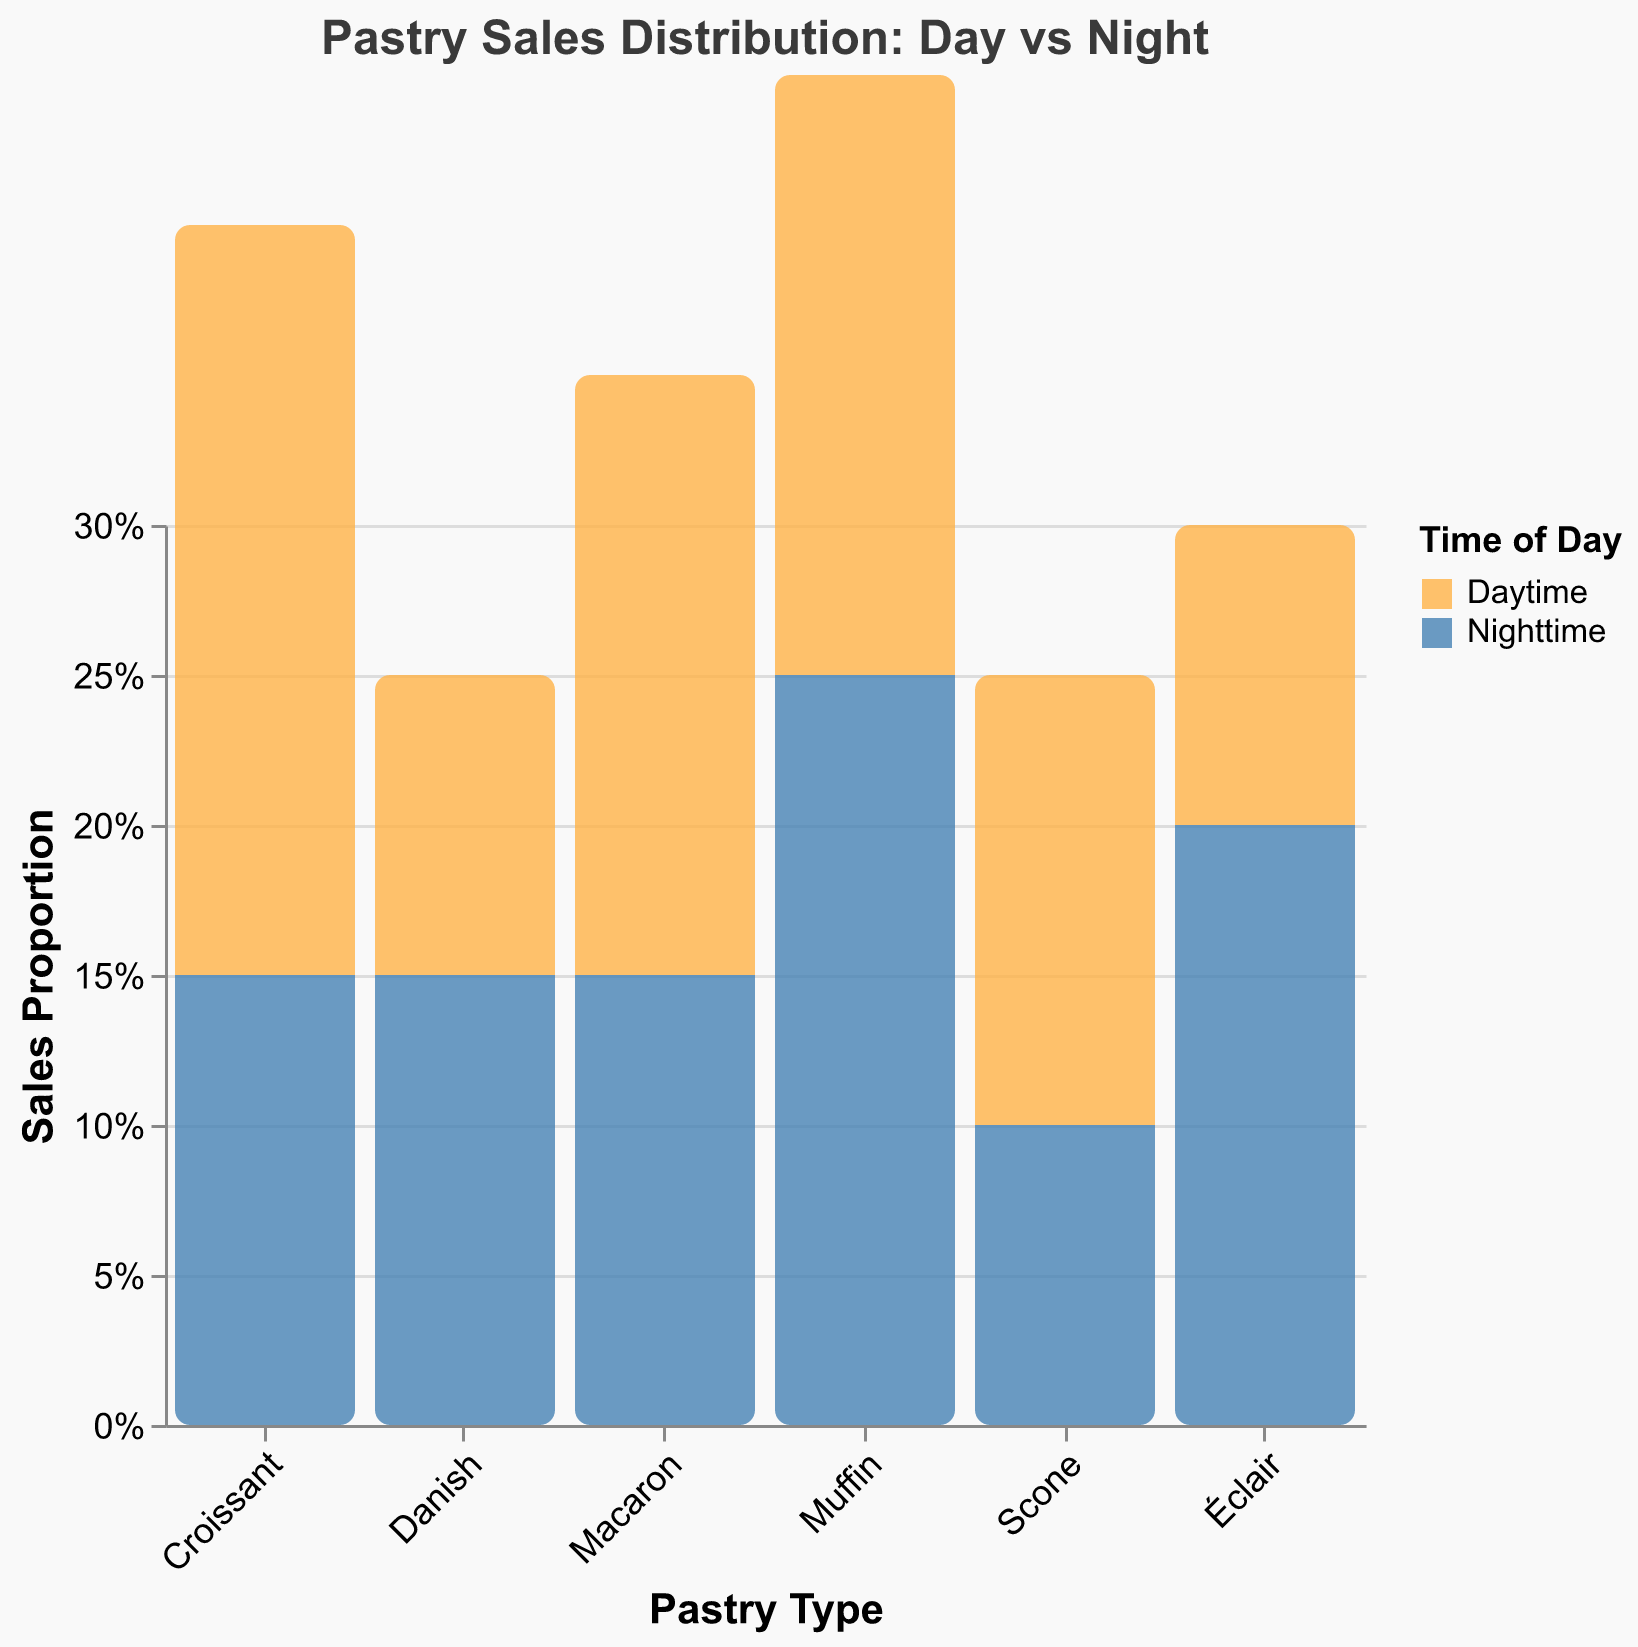What is the title of the chart? The title of the chart is displayed at the top of the figure.
Answer: Pastry Sales Distribution: Day vs Night What colors represent daytime and nighttime in the chart? The legend at the right of the chart shows the relationship between colors and time of day. Daytime is represented by an orange color, and nighttime is represented by a blue color.
Answer: Orange for daytime and blue for nighttime Which pastry type has the highest sales proportion during nighttime? By looking at the different bars colored in blue, we find the tallest bar for nighttime sales proportion. The Éclair bar is the highest at nighttime with a sales proportion of 0.20.
Answer: Éclair How does the sales proportion of muffins compare between daytime and nighttime? Look at the two bars for Muffin; one represents daytime (orange) and the other represents nighttime (blue). The bar for nighttime is taller, indicating a higher sales proportion during nighttime (0.25) than during daytime (0.20).
Answer: Nighttime sales proportion is higher Which pastry type has the smallest difference in sales proportion between daytime and nighttime? Calculate the difference in sales proportion for each pastry type, then find the smallest difference. For Danish, the difference is 0.15 - 0.10 = 0.05, which is the smallest difference among the pastry types.
Answer: Danish What is the total sales proportion during daytime for all pastries? Sum the sales proportions for each pastry type during daytime. 0.25 (Croissant) + 0.20 (Muffin) + 0.10 (Danish) + 0.15 (Scone) + 0.10 (Éclair) + 0.20 (Macaron) = 1.00
Answer: 1.00 What is the average sales proportion of all pastries during nighttime? Sum the sales proportions for each pastry type during nighttime and then divide by the number of pastry types. (0.15 + 0.25 + 0.15 + 0.10 + 0.20 + 0.15) / 6 = 1.00 / 6 = 0.1667
Answer: 0.1667 Which two pastries have the same sales proportion during nighttime? Examine the blue bars for all pastries and find the ones with equal heights. Both Danish and Macaron have a sales proportion of 0.15 during nighttime.
Answer: Danish and Macaron 